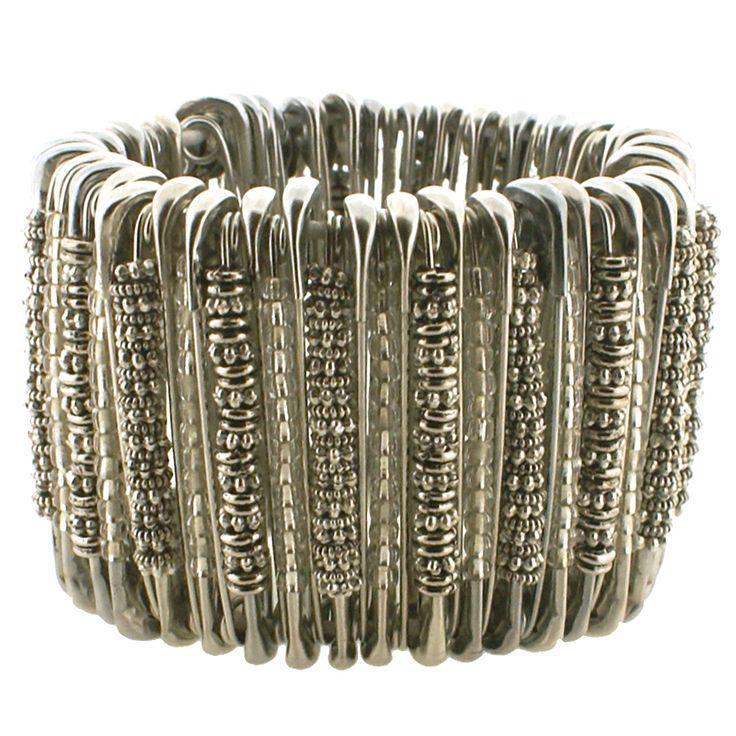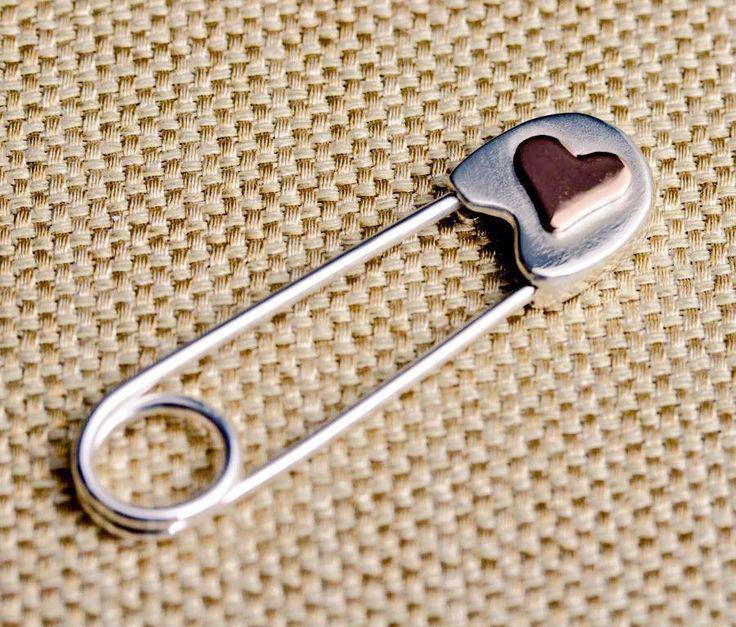The first image is the image on the left, the second image is the image on the right. Given the left and right images, does the statement "One picture features jewelry made from safety pins that is meant to be worn around one's wrist." hold true? Answer yes or no. Yes. The first image is the image on the left, the second image is the image on the right. Given the left and right images, does the statement "An image shows a bracelet made of one color of safety pins, strung with beads." hold true? Answer yes or no. Yes. 